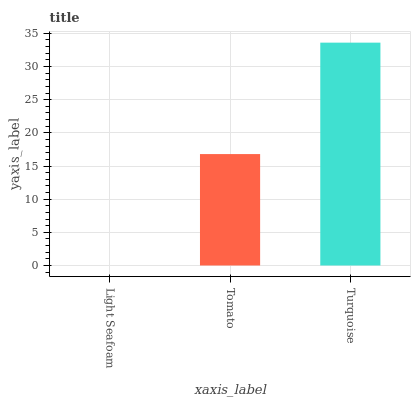Is Light Seafoam the minimum?
Answer yes or no. Yes. Is Turquoise the maximum?
Answer yes or no. Yes. Is Tomato the minimum?
Answer yes or no. No. Is Tomato the maximum?
Answer yes or no. No. Is Tomato greater than Light Seafoam?
Answer yes or no. Yes. Is Light Seafoam less than Tomato?
Answer yes or no. Yes. Is Light Seafoam greater than Tomato?
Answer yes or no. No. Is Tomato less than Light Seafoam?
Answer yes or no. No. Is Tomato the high median?
Answer yes or no. Yes. Is Tomato the low median?
Answer yes or no. Yes. Is Turquoise the high median?
Answer yes or no. No. Is Turquoise the low median?
Answer yes or no. No. 